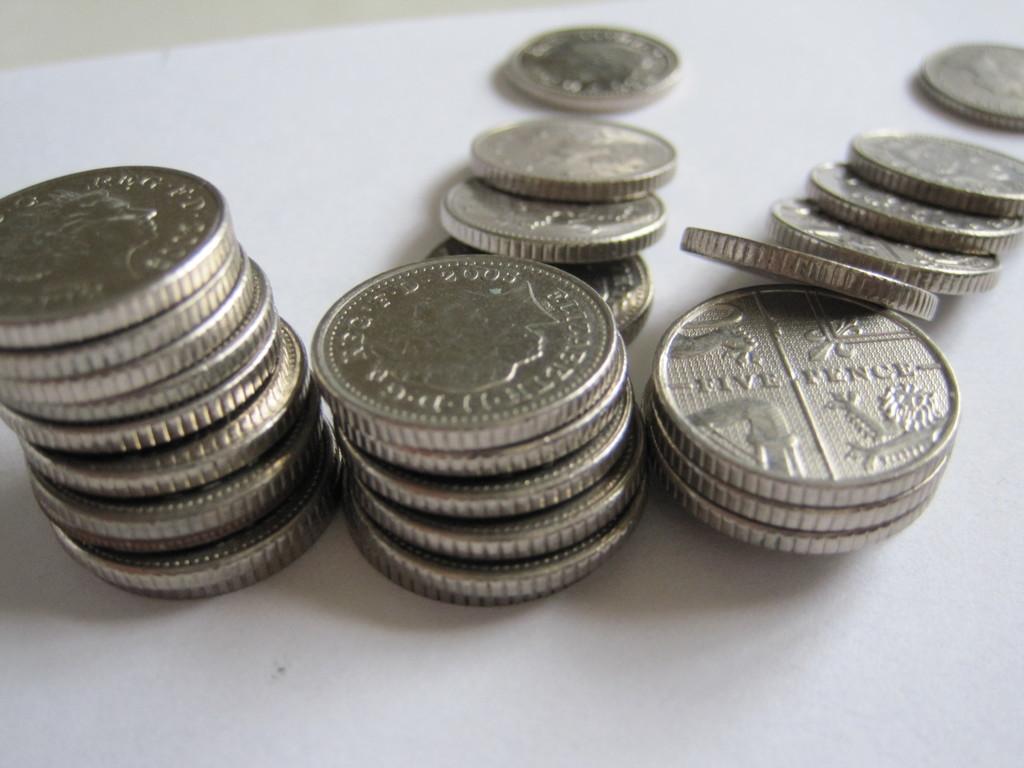How many pence is the right coin worth?
Provide a short and direct response. Five. The coin is five what?
Make the answer very short. Pence. 